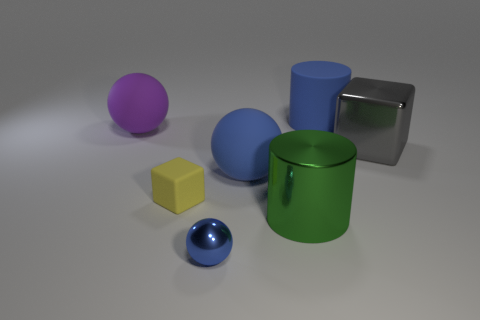Add 1 large gray matte things. How many objects exist? 8 Subtract all blue matte spheres. How many spheres are left? 2 Subtract all green cylinders. How many blue balls are left? 2 Subtract all purple spheres. How many spheres are left? 2 Subtract all cubes. How many objects are left? 5 Add 5 purple things. How many purple things are left? 6 Add 1 small yellow rubber objects. How many small yellow rubber objects exist? 2 Subtract 1 yellow cubes. How many objects are left? 6 Subtract all yellow spheres. Subtract all brown cylinders. How many spheres are left? 3 Subtract all small blue metal things. Subtract all big green shiny objects. How many objects are left? 5 